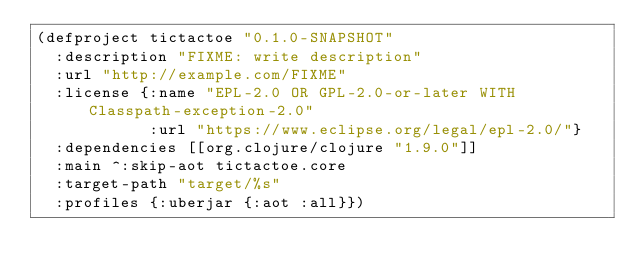<code> <loc_0><loc_0><loc_500><loc_500><_Clojure_>(defproject tictactoe "0.1.0-SNAPSHOT"
  :description "FIXME: write description"
  :url "http://example.com/FIXME"
  :license {:name "EPL-2.0 OR GPL-2.0-or-later WITH Classpath-exception-2.0"
            :url "https://www.eclipse.org/legal/epl-2.0/"}
  :dependencies [[org.clojure/clojure "1.9.0"]]
  :main ^:skip-aot tictactoe.core
  :target-path "target/%s"
  :profiles {:uberjar {:aot :all}})
</code> 